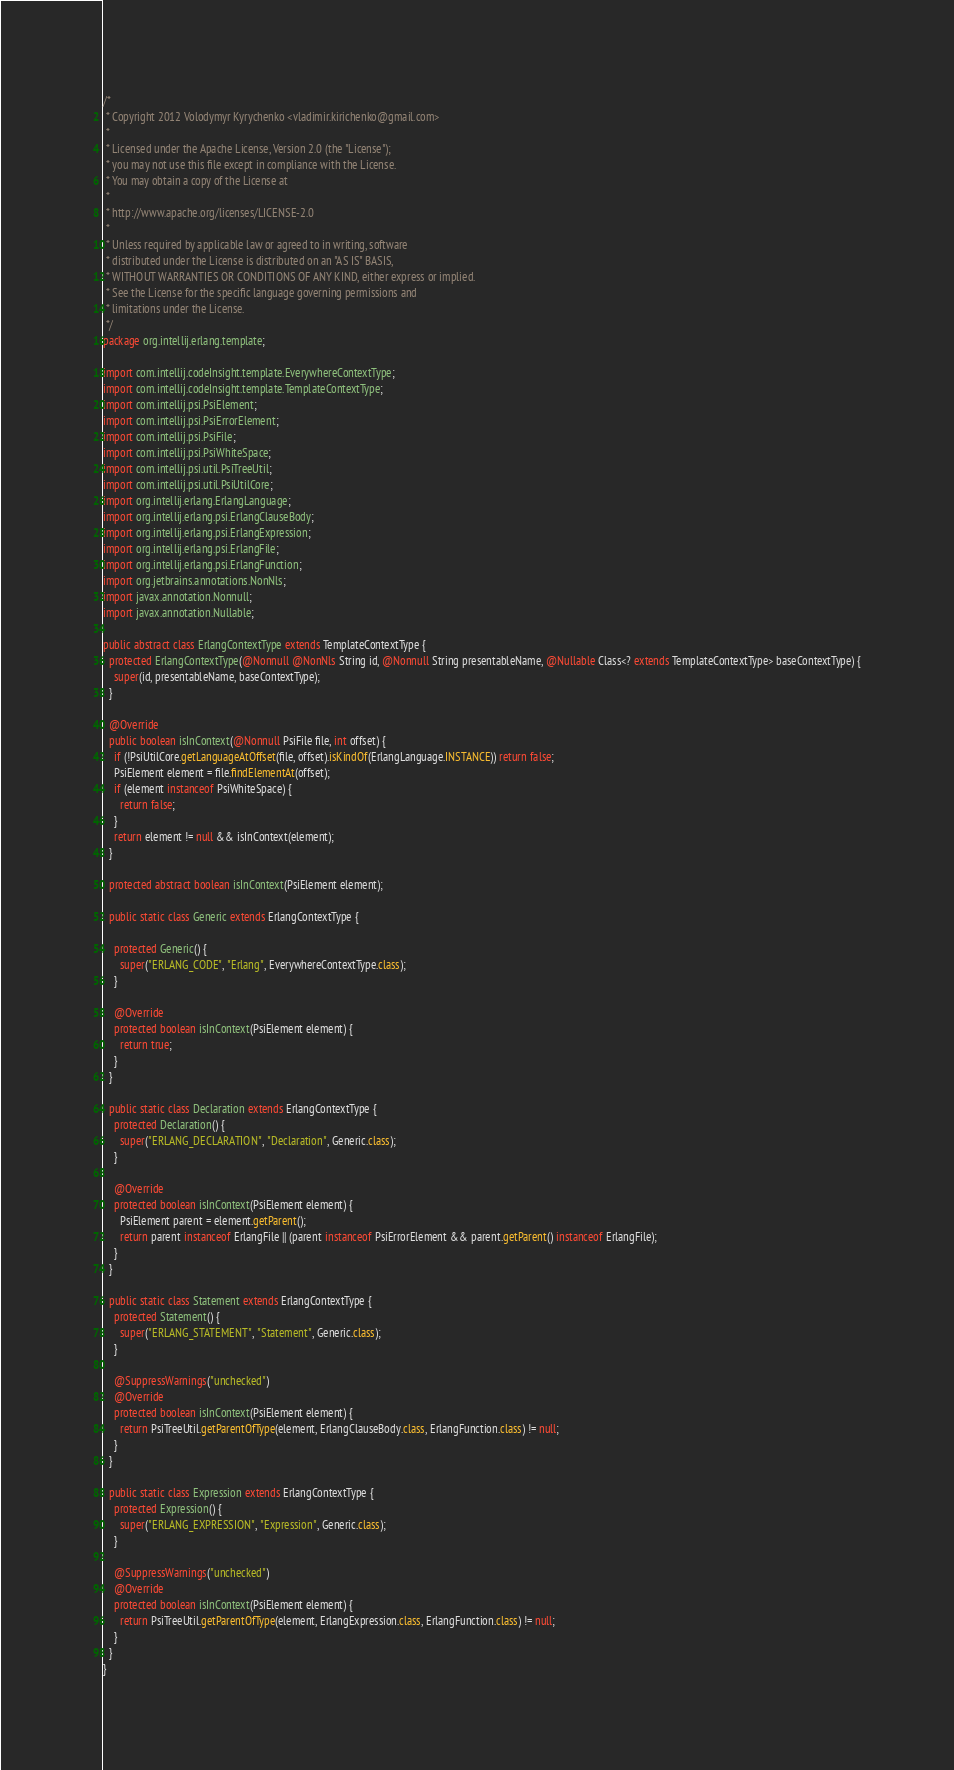Convert code to text. <code><loc_0><loc_0><loc_500><loc_500><_Java_>/*
 * Copyright 2012 Volodymyr Kyrychenko <vladimir.kirichenko@gmail.com>
 *
 * Licensed under the Apache License, Version 2.0 (the "License");
 * you may not use this file except in compliance with the License.
 * You may obtain a copy of the License at
 *
 * http://www.apache.org/licenses/LICENSE-2.0
 *
 * Unless required by applicable law or agreed to in writing, software
 * distributed under the License is distributed on an "AS IS" BASIS,
 * WITHOUT WARRANTIES OR CONDITIONS OF ANY KIND, either express or implied.
 * See the License for the specific language governing permissions and
 * limitations under the License.
 */
package org.intellij.erlang.template;

import com.intellij.codeInsight.template.EverywhereContextType;
import com.intellij.codeInsight.template.TemplateContextType;
import com.intellij.psi.PsiElement;
import com.intellij.psi.PsiErrorElement;
import com.intellij.psi.PsiFile;
import com.intellij.psi.PsiWhiteSpace;
import com.intellij.psi.util.PsiTreeUtil;
import com.intellij.psi.util.PsiUtilCore;
import org.intellij.erlang.ErlangLanguage;
import org.intellij.erlang.psi.ErlangClauseBody;
import org.intellij.erlang.psi.ErlangExpression;
import org.intellij.erlang.psi.ErlangFile;
import org.intellij.erlang.psi.ErlangFunction;
import org.jetbrains.annotations.NonNls;
import javax.annotation.Nonnull;
import javax.annotation.Nullable;

public abstract class ErlangContextType extends TemplateContextType {
  protected ErlangContextType(@Nonnull @NonNls String id, @Nonnull String presentableName, @Nullable Class<? extends TemplateContextType> baseContextType) {
    super(id, presentableName, baseContextType);
  }

  @Override
  public boolean isInContext(@Nonnull PsiFile file, int offset) {
    if (!PsiUtilCore.getLanguageAtOffset(file, offset).isKindOf(ErlangLanguage.INSTANCE)) return false;
    PsiElement element = file.findElementAt(offset);
    if (element instanceof PsiWhiteSpace) {
      return false;
    }
    return element != null && isInContext(element);
  }

  protected abstract boolean isInContext(PsiElement element);

  public static class Generic extends ErlangContextType {

    protected Generic() {
      super("ERLANG_CODE", "Erlang", EverywhereContextType.class);
    }

    @Override
    protected boolean isInContext(PsiElement element) {
      return true;
    }
  }

  public static class Declaration extends ErlangContextType {
    protected Declaration() {
      super("ERLANG_DECLARATION", "Declaration", Generic.class);
    }

    @Override
    protected boolean isInContext(PsiElement element) {
      PsiElement parent = element.getParent();
      return parent instanceof ErlangFile || (parent instanceof PsiErrorElement && parent.getParent() instanceof ErlangFile);
    }
  }

  public static class Statement extends ErlangContextType {
    protected Statement() {
      super("ERLANG_STATEMENT", "Statement", Generic.class);
    }

    @SuppressWarnings("unchecked")
    @Override
    protected boolean isInContext(PsiElement element) {
      return PsiTreeUtil.getParentOfType(element, ErlangClauseBody.class, ErlangFunction.class) != null;
    }
  }

  public static class Expression extends ErlangContextType {
    protected Expression() {
      super("ERLANG_EXPRESSION", "Expression", Generic.class);
    }

    @SuppressWarnings("unchecked")
    @Override
    protected boolean isInContext(PsiElement element) {
      return PsiTreeUtil.getParentOfType(element, ErlangExpression.class, ErlangFunction.class) != null;
    }
  }
}
</code> 